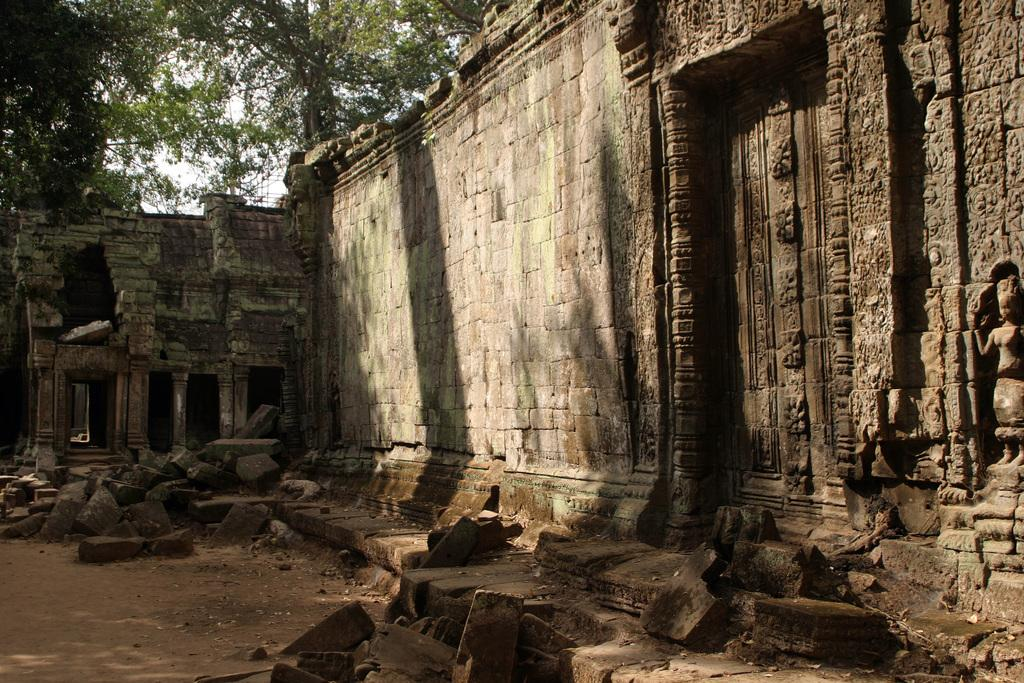What can be seen on the ground in the image? There are stones on the ground in the image. What structure is visible on the right side and in the background of the image? There is a wall on the right side and in the background of the image. What type of vegetation can be seen in the top left side of the image? There are trees visible in the top left side of the image. How many letters are visible on the elbow of the person in the image? There is no person present in the image, and therefore no elbow or letters can be observed. 